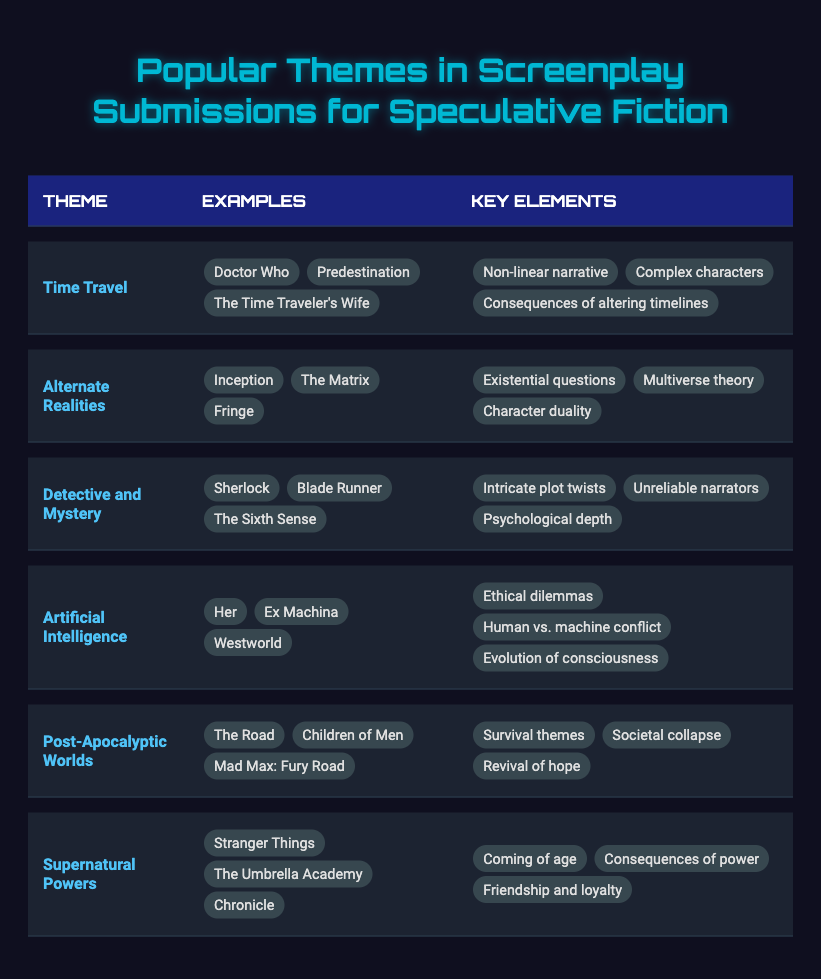What is one example of a screenplay that features the theme of "Time Travel"? The table lists several examples under the "Time Travel" theme, including "Doctor Who," "Predestination," and "The Time Traveler's Wife." Any of these can be considered an example.
Answer: Doctor Who Which theme involves the concept of multiverse theory? The "Alternate Realities" theme includes key elements such as multiverse theory, as stated in the table.
Answer: Alternate Realities Are there any themes listed that include elements of societal collapse? Looking at the table, "Post-Apocalyptic Worlds" has key elements that include societal collapse. Therefore, the answer is yes.
Answer: Yes How many themes are there that feature ethical dilemmas as a key element? The table shows that "Artificial Intelligence" includes ethical dilemmas as a key element, while no other themes in the table do. Thus, only one theme fits this criterion.
Answer: 1 What themes have examples that include "Sherlock" and "Stranger Things"? "Sherlock" is associated with the "Detective and Mystery" theme, while "Stranger Things" falls under the "Supernatural Powers" theme. Both themes are distinctly different.
Answer: Different themes Which theme has the greatest number of key elements listed? By reviewing the table, we see that each theme is detailed with three key elements, so they all have the same count. Therefore, there is no single theme with the most key elements.
Answer: All have the same number What combination of themes includes both psychological depth and complex characters? The "Detective and Mystery" theme includes psychological depth, while "Time Travel" features complex characters. However, they cannot combine into a single theme with both elements.
Answer: Multiple themes Which theme has examples that deal with survival themes? The "Post-Apocalyptic Worlds" theme explicitly mentions survival themes among its key elements, making it the relevant theme for this aspect.
Answer: Post-Apocalyptic Worlds Are there any themes that discuss the consequences of power? The table indicates that "Supernatural Powers" discusses the consequences of power as one of its key elements, confirming its presence.
Answer: Yes How many of the themes focus on the development of consciousness? The "Artificial Intelligence" theme specifically includes evolution of consciousness as a key element. No other themes listed focus on consciousness. Therefore, there is only one theme.
Answer: 1 